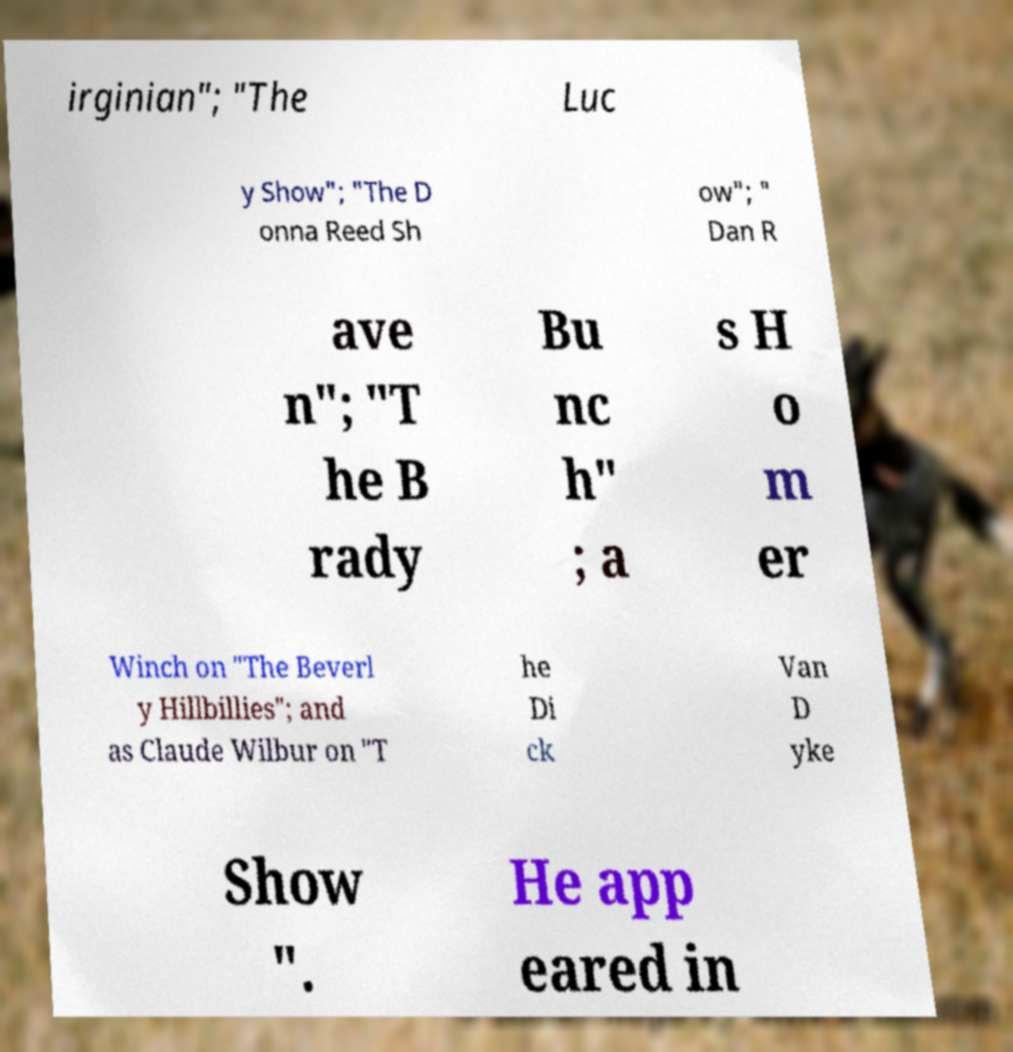There's text embedded in this image that I need extracted. Can you transcribe it verbatim? irginian"; "The Luc y Show"; "The D onna Reed Sh ow"; " Dan R ave n"; "T he B rady Bu nc h" ; a s H o m er Winch on "The Beverl y Hillbillies"; and as Claude Wilbur on "T he Di ck Van D yke Show ". He app eared in 